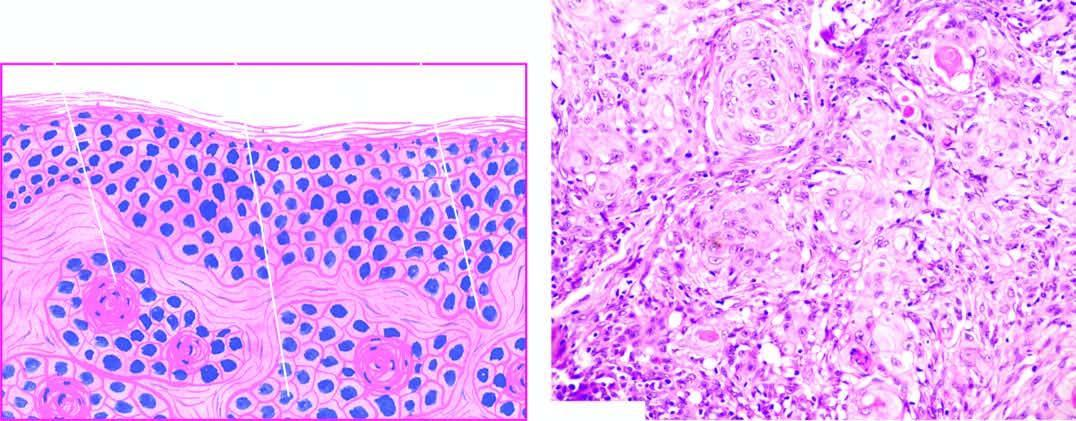does microscopy show whorls of malignant squamous cells with central keratin pearls?
Answer the question using a single word or phrase. Yes 